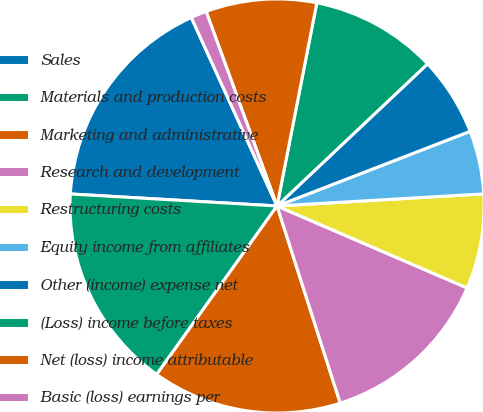<chart> <loc_0><loc_0><loc_500><loc_500><pie_chart><fcel>Sales<fcel>Materials and production costs<fcel>Marketing and administrative<fcel>Research and development<fcel>Restructuring costs<fcel>Equity income from affiliates<fcel>Other (income) expense net<fcel>(Loss) income before taxes<fcel>Net (loss) income attributable<fcel>Basic (loss) earnings per<nl><fcel>17.28%<fcel>16.05%<fcel>14.81%<fcel>13.58%<fcel>7.41%<fcel>4.94%<fcel>6.17%<fcel>9.88%<fcel>8.64%<fcel>1.23%<nl></chart> 